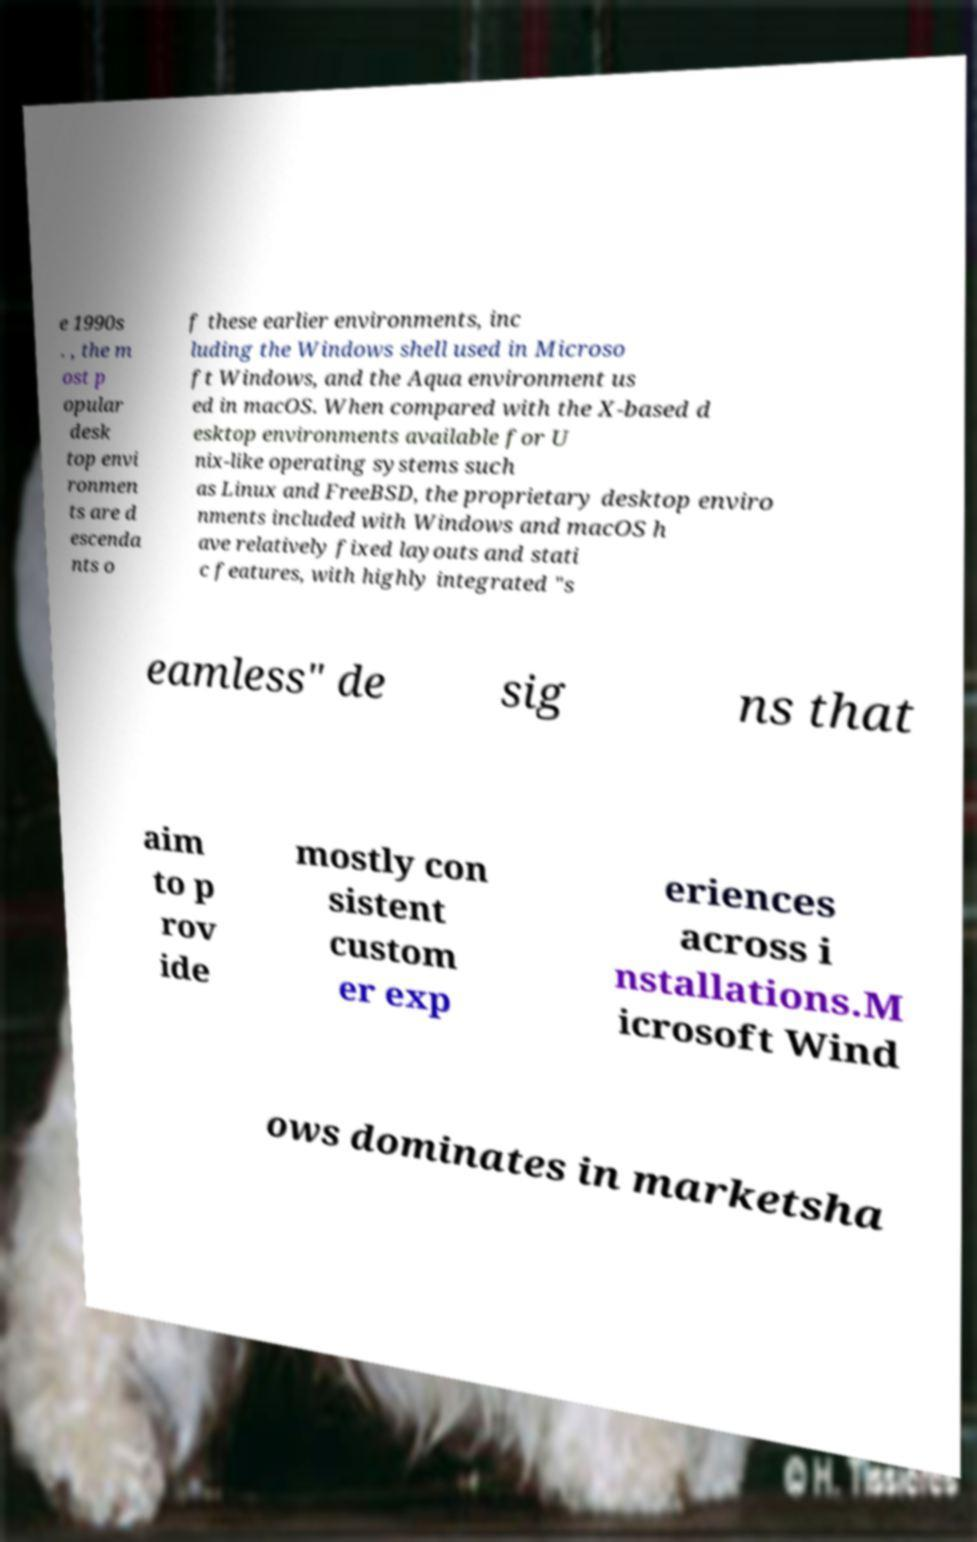I need the written content from this picture converted into text. Can you do that? e 1990s . , the m ost p opular desk top envi ronmen ts are d escenda nts o f these earlier environments, inc luding the Windows shell used in Microso ft Windows, and the Aqua environment us ed in macOS. When compared with the X-based d esktop environments available for U nix-like operating systems such as Linux and FreeBSD, the proprietary desktop enviro nments included with Windows and macOS h ave relatively fixed layouts and stati c features, with highly integrated "s eamless" de sig ns that aim to p rov ide mostly con sistent custom er exp eriences across i nstallations.M icrosoft Wind ows dominates in marketsha 